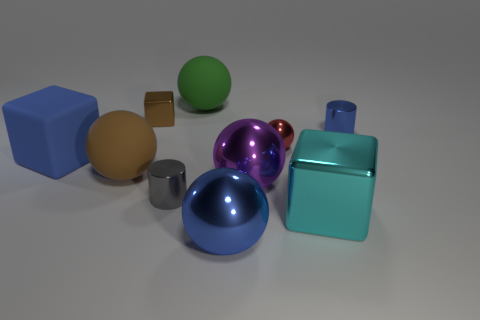Subtract all blue spheres. How many spheres are left? 4 Subtract all green balls. How many balls are left? 4 Subtract all gray balls. Subtract all cyan cylinders. How many balls are left? 5 Subtract all cylinders. How many objects are left? 8 Subtract all small gray rubber cylinders. Subtract all green matte spheres. How many objects are left? 9 Add 6 brown objects. How many brown objects are left? 8 Add 8 rubber spheres. How many rubber spheres exist? 10 Subtract 0 green blocks. How many objects are left? 10 